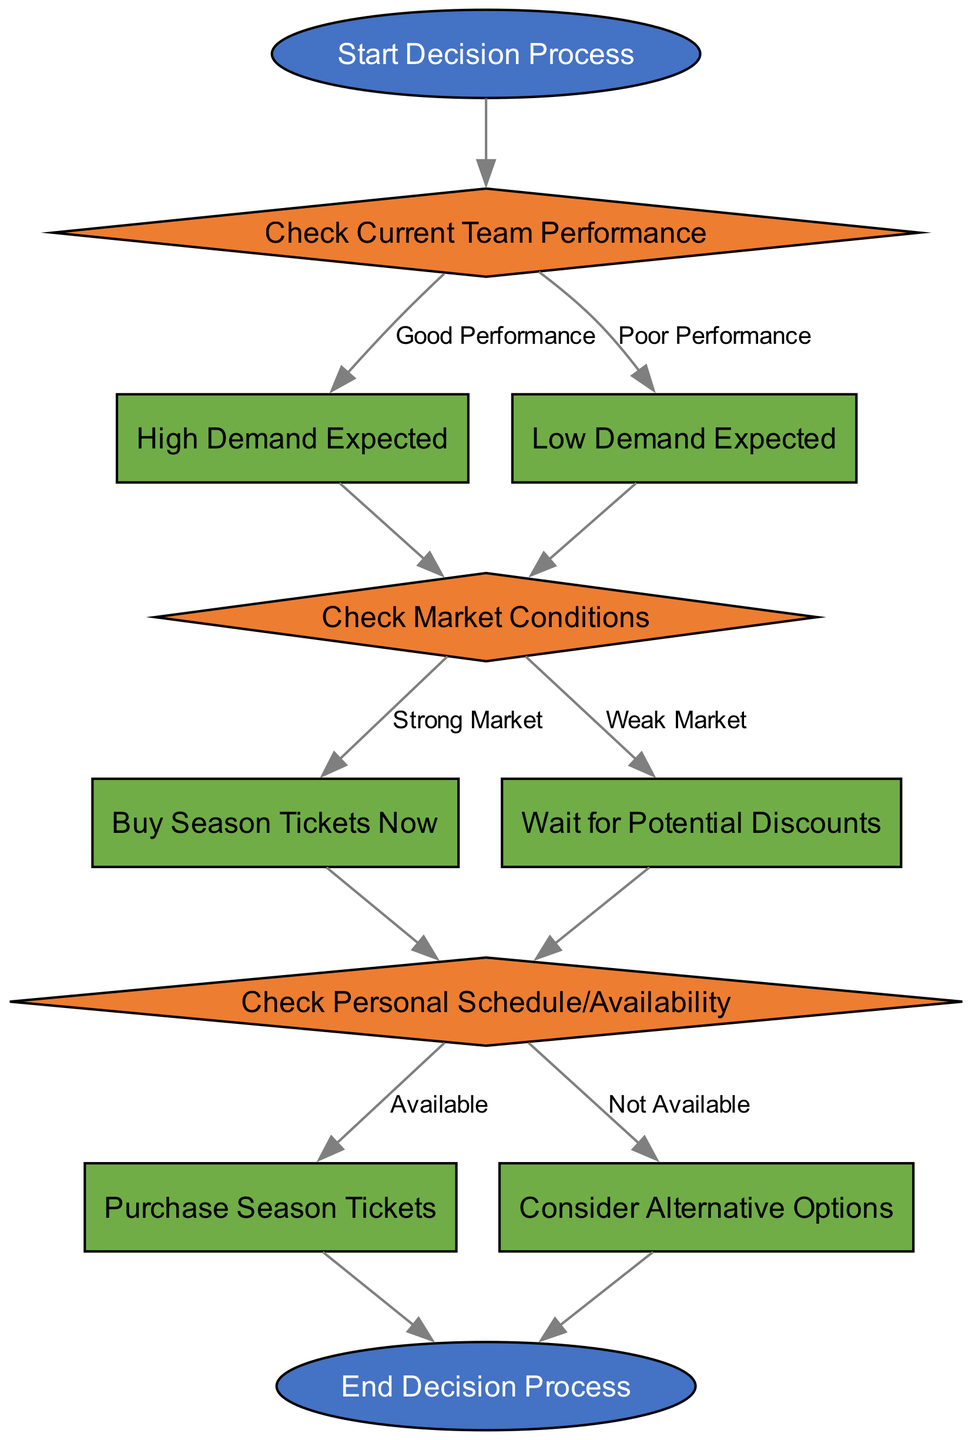What is the starting point of the diagram? The starting point of the diagram is labeled "Start Decision Process," which indicates where the decision-making flow begins.
Answer: Start Decision Process How many decision nodes are present in the diagram? The diagram contains three decision nodes: "Check Current Team Performance," "Check Market Conditions," and "Check Personal Schedule/Availability."
Answer: Three What is the outcome if the team performance is classified as poor? If the team performance is classified as poor, the next step is "Low Demand Expected." This indicates that the situation will lead towards a scenario of low ticket demand.
Answer: Low Demand Expected What action is taken when the market conditions are strong? When market conditions are strong, the action taken is to "Buy Season Tickets Now," indicating that it is advantageous to purchase tickets immediately.
Answer: Buy Season Tickets Now If personal availability is classified as not available, what is the next step? If personal availability is classified as not available, then the next step is to "Consider Alternative Options," which suggests that the individual may need to look for other possibilities for viewing the games.
Answer: Consider Alternative Options How does one transition from high demand to further evaluation? After identifying high demand, the flowchart directs to the "Check Market Conditions" node, which involves evaluating the current market before making a decision.
Answer: Check Market Conditions What happens if market conditions are weak? If market conditions are weak, the diagram indicates that the choice would be to "Wait for Potential Discounts," suggesting a postponement of the purchase until better market conditions arise.
Answer: Wait for Potential Discounts What is the final node in the decision process? The final node in the decision process is labeled "End Decision Process," indicating the conclusion of the flow after all evaluations and decisions have been made.
Answer: End Decision Process 